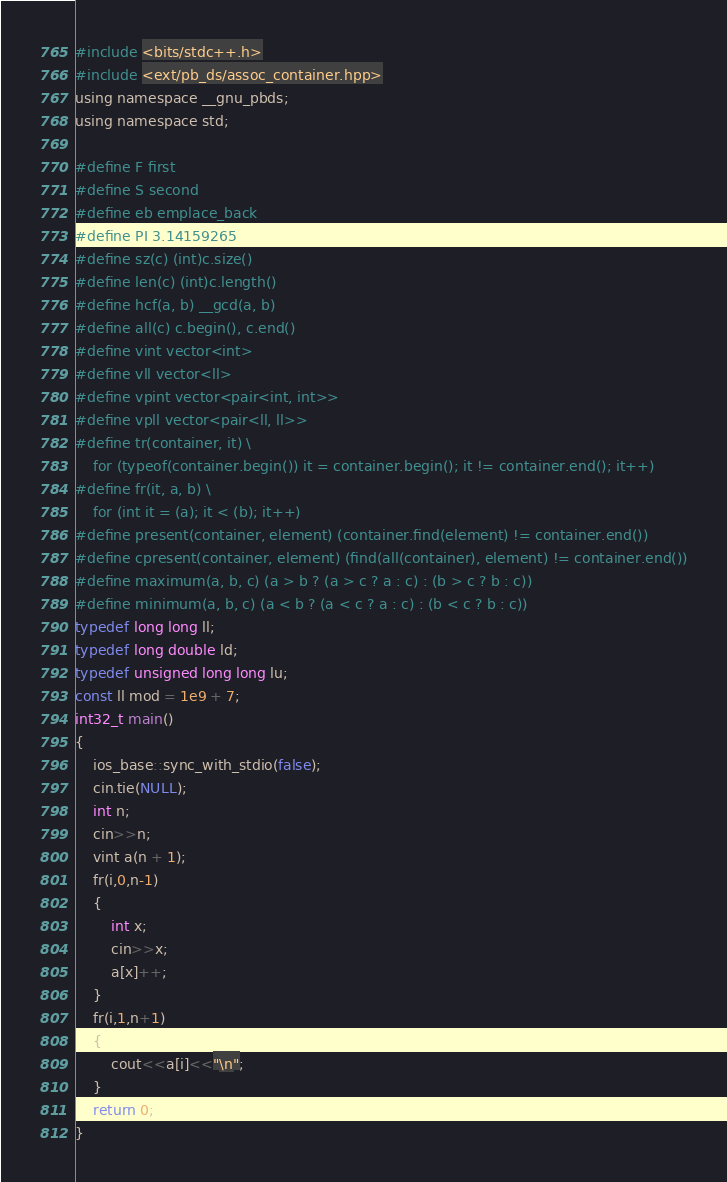<code> <loc_0><loc_0><loc_500><loc_500><_C_>#include <bits/stdc++.h>
#include <ext/pb_ds/assoc_container.hpp>
using namespace __gnu_pbds;
using namespace std;

#define F first
#define S second
#define eb emplace_back
#define PI 3.14159265
#define sz(c) (int)c.size()
#define len(c) (int)c.length()
#define hcf(a, b) __gcd(a, b)
#define all(c) c.begin(), c.end()
#define vint vector<int>
#define vll vector<ll>
#define vpint vector<pair<int, int>>
#define vpll vector<pair<ll, ll>>
#define tr(container, it) \
    for (typeof(container.begin()) it = container.begin(); it != container.end(); it++)
#define fr(it, a, b) \
    for (int it = (a); it < (b); it++)
#define present(container, element) (container.find(element) != container.end())
#define cpresent(container, element) (find(all(container), element) != container.end())
#define maximum(a, b, c) (a > b ? (a > c ? a : c) : (b > c ? b : c))
#define minimum(a, b, c) (a < b ? (a < c ? a : c) : (b < c ? b : c))
typedef long long ll;
typedef long double ld;
typedef unsigned long long lu;
const ll mod = 1e9 + 7;
int32_t main()
{
    ios_base::sync_with_stdio(false);
    cin.tie(NULL);
    int n;
    cin>>n;
    vint a(n + 1);
    fr(i,0,n-1)
    {
        int x;
        cin>>x;
        a[x]++;
    }
    fr(i,1,n+1)
    {
        cout<<a[i]<<"\n";
    }
    return 0;
}</code> 